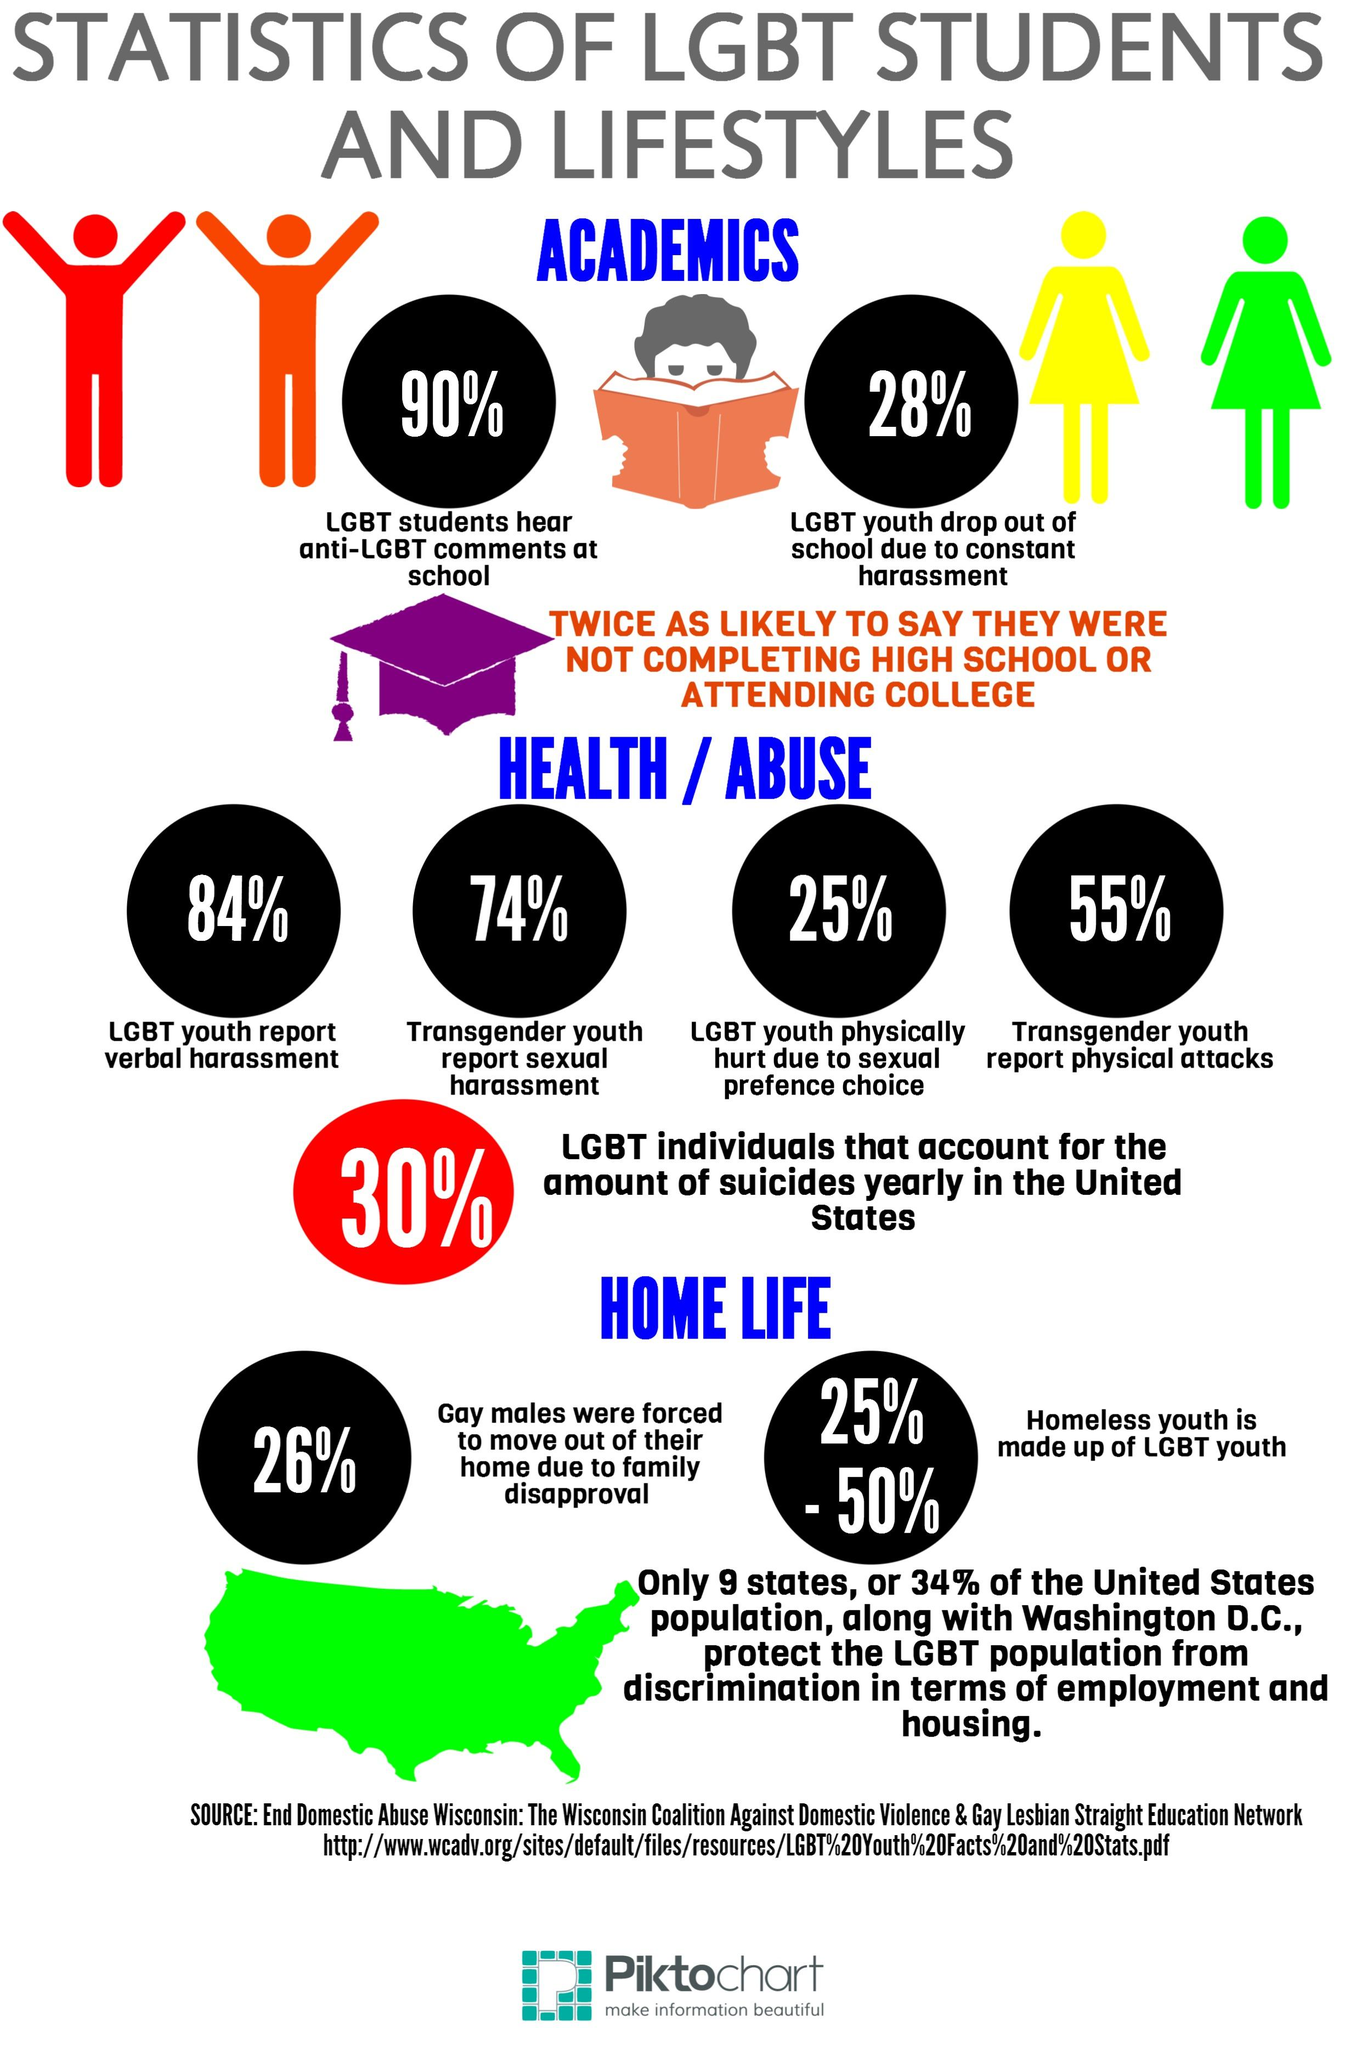Outline some significant characteristics in this image. The percentage of the LGBT community that reports abuse is 238%. According to a recent study, only 10% of LGBT students reported not hearing any anti-LGBT comments at school. In 41 states, the LGBT population is not protected from discrimination. 